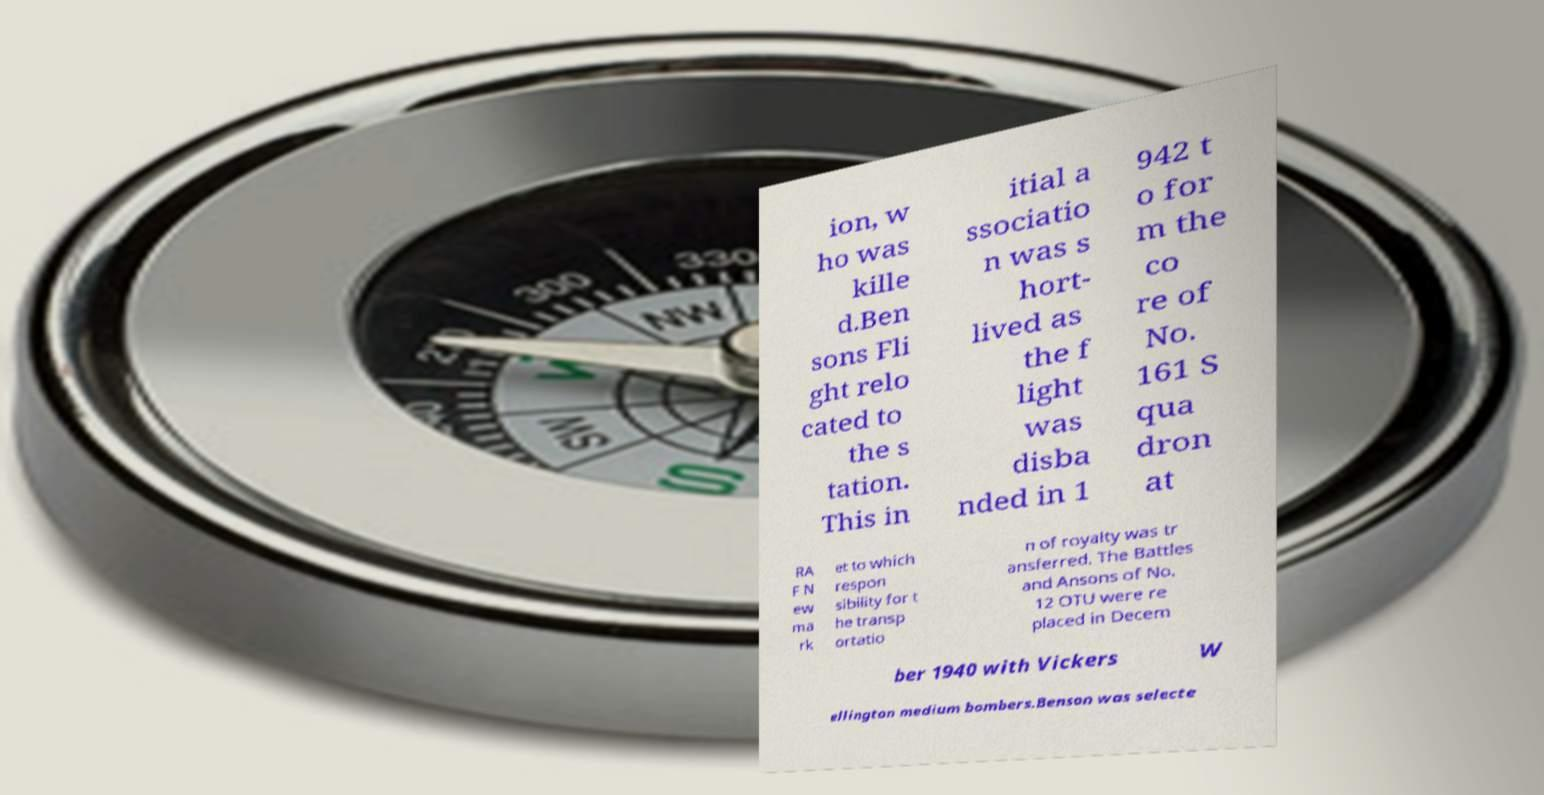Can you read and provide the text displayed in the image?This photo seems to have some interesting text. Can you extract and type it out for me? ion, w ho was kille d.Ben sons Fli ght relo cated to the s tation. This in itial a ssociatio n was s hort- lived as the f light was disba nded in 1 942 t o for m the co re of No. 161 S qua dron at RA F N ew ma rk et to which respon sibility for t he transp ortatio n of royalty was tr ansferred. The Battles and Ansons of No. 12 OTU were re placed in Decem ber 1940 with Vickers W ellington medium bombers.Benson was selecte 